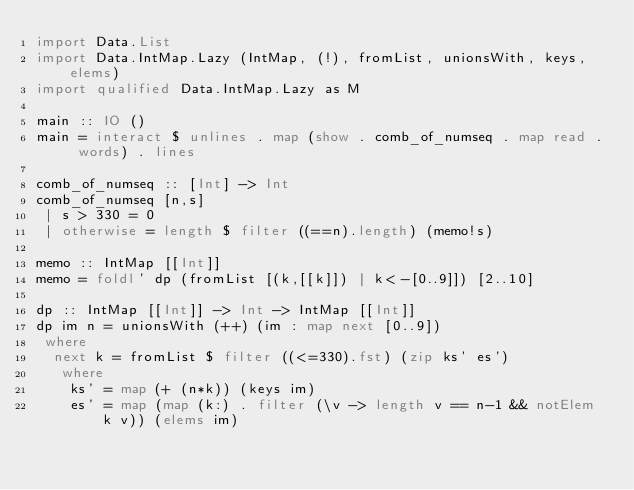Convert code to text. <code><loc_0><loc_0><loc_500><loc_500><_Haskell_>import Data.List
import Data.IntMap.Lazy (IntMap, (!), fromList, unionsWith, keys, elems)
import qualified Data.IntMap.Lazy as M

main :: IO ()
main = interact $ unlines . map (show . comb_of_numseq . map read . words) . lines

comb_of_numseq :: [Int] -> Int
comb_of_numseq [n,s]
 | s > 330 = 0
 | otherwise = length $ filter ((==n).length) (memo!s)

memo :: IntMap [[Int]]
memo = foldl' dp (fromList [(k,[[k]]) | k<-[0..9]]) [2..10]

dp :: IntMap [[Int]] -> Int -> IntMap [[Int]]
dp im n = unionsWith (++) (im : map next [0..9])
 where
  next k = fromList $ filter ((<=330).fst) (zip ks' es')
   where
    ks' = map (+ (n*k)) (keys im)
    es' = map (map (k:) . filter (\v -> length v == n-1 && notElem k v)) (elems im)</code> 